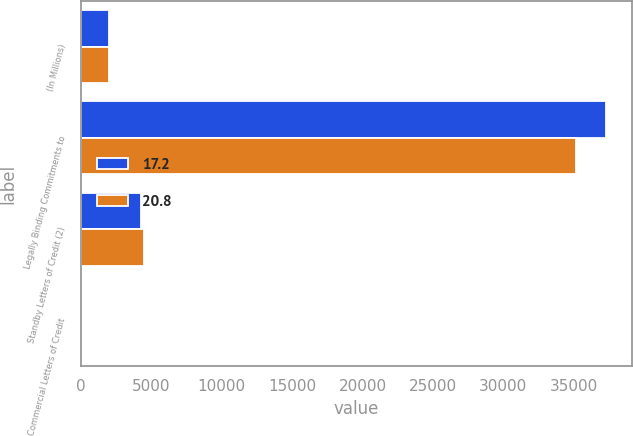<chart> <loc_0><loc_0><loc_500><loc_500><stacked_bar_chart><ecel><fcel>(In Millions)<fcel>Legally Binding Commitments to<fcel>Standby Letters of Credit (2)<fcel>Commercial Letters of Credit<nl><fcel>17.2<fcel>2015<fcel>37247<fcel>4305.4<fcel>17.2<nl><fcel>20.8<fcel>2014<fcel>35127.6<fcel>4468.1<fcel>20.8<nl></chart> 